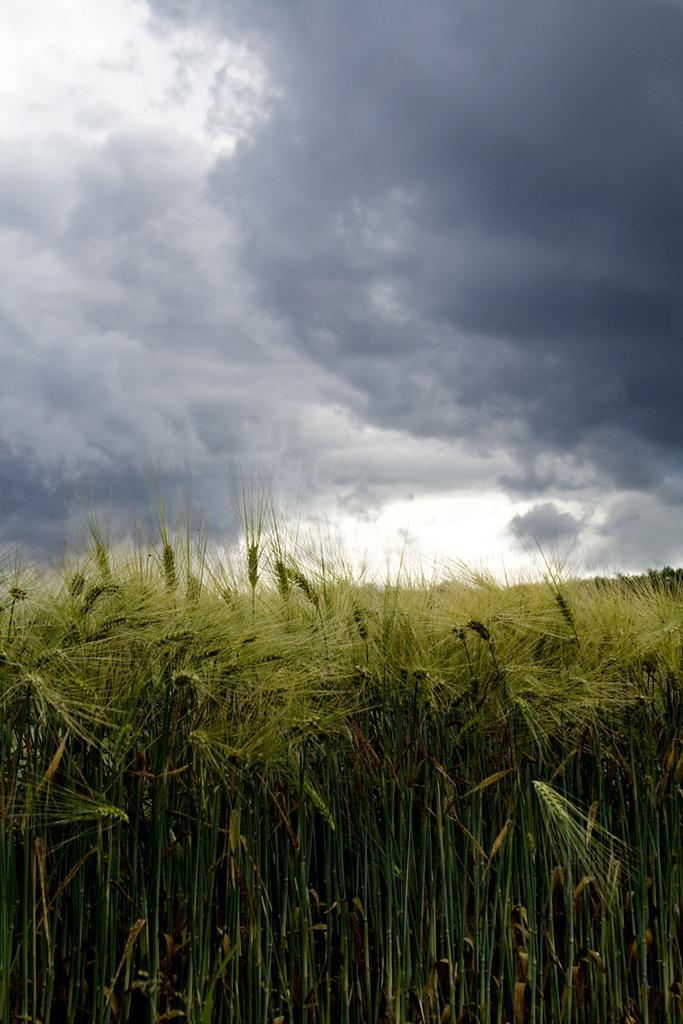Could you give a brief overview of what you see in this image? At the bottom of the image we can see the wheat field. At the top of the image we can see the clouds are present in the sky. 